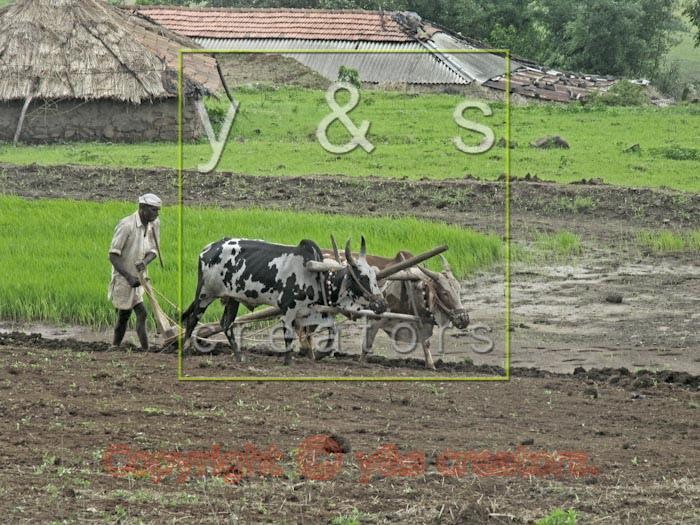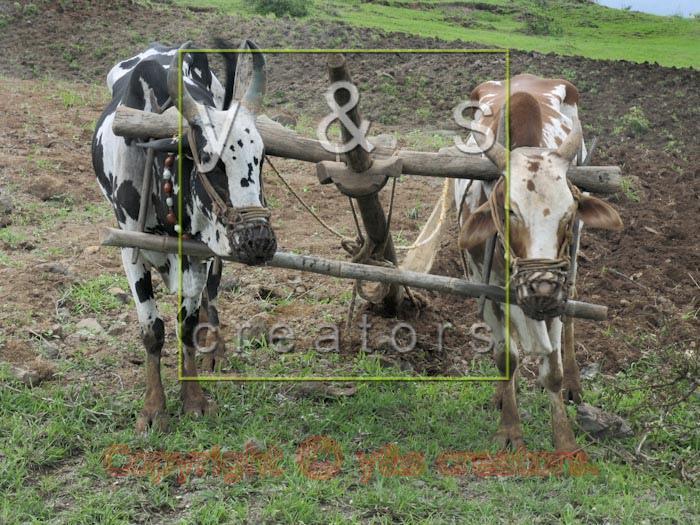The first image is the image on the left, the second image is the image on the right. Evaluate the accuracy of this statement regarding the images: "In one of the images there are 2 people wearing a hat.". Is it true? Answer yes or no. No. The first image is the image on the left, the second image is the image on the right. Assess this claim about the two images: "One image includes two spotted oxen pulling a plow, and the other image shows a plow team with at least two solid black oxen.". Correct or not? Answer yes or no. No. 